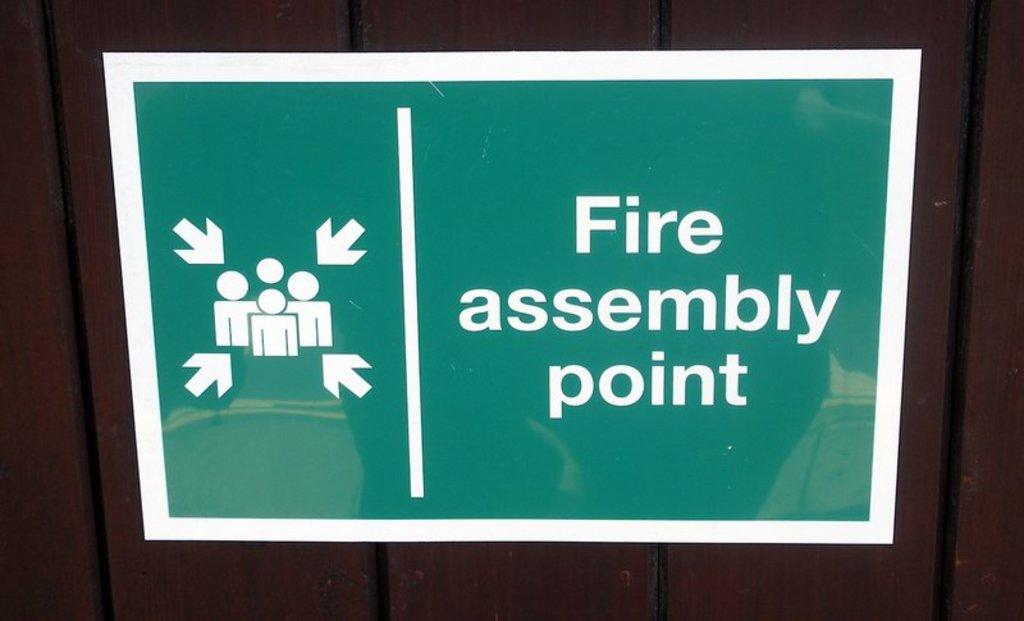<image>
Render a clear and concise summary of the photo. a sign showing the assembly point in case of a fire 